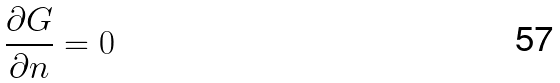Convert formula to latex. <formula><loc_0><loc_0><loc_500><loc_500>\frac { \partial G } { \partial n } = 0</formula> 